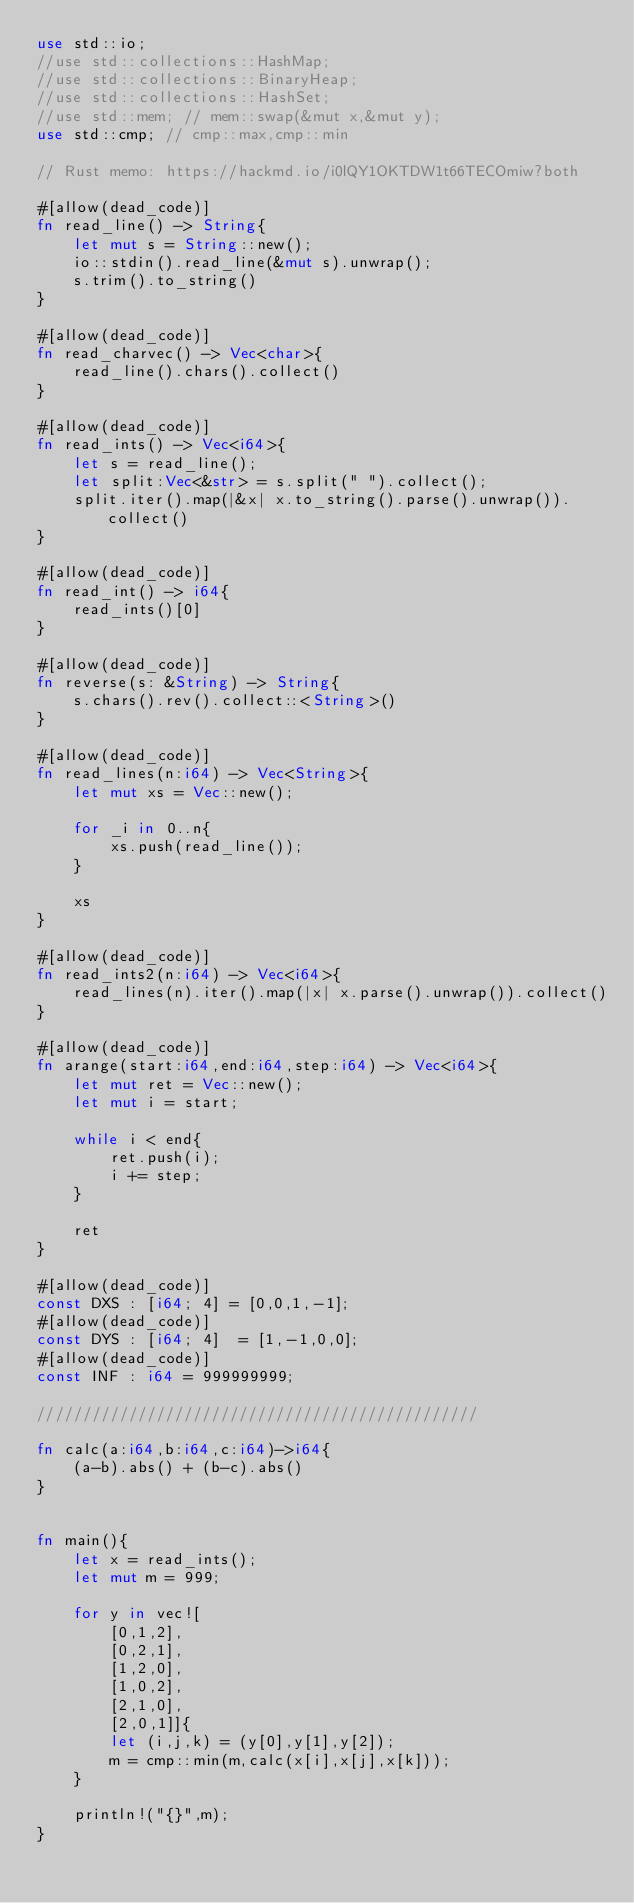Convert code to text. <code><loc_0><loc_0><loc_500><loc_500><_Rust_>use std::io;
//use std::collections::HashMap;
//use std::collections::BinaryHeap;
//use std::collections::HashSet;
//use std::mem; // mem::swap(&mut x,&mut y);
use std::cmp; // cmp::max,cmp::min

// Rust memo: https://hackmd.io/i0lQY1OKTDW1t66TECOmiw?both

#[allow(dead_code)]
fn read_line() -> String{
    let mut s = String::new();
    io::stdin().read_line(&mut s).unwrap();
    s.trim().to_string()
}

#[allow(dead_code)]
fn read_charvec() -> Vec<char>{
    read_line().chars().collect()
}

#[allow(dead_code)]
fn read_ints() -> Vec<i64>{
    let s = read_line();
    let split:Vec<&str> = s.split(" ").collect();
    split.iter().map(|&x| x.to_string().parse().unwrap()).collect()
}

#[allow(dead_code)]
fn read_int() -> i64{
    read_ints()[0]
}

#[allow(dead_code)]
fn reverse(s: &String) -> String{
    s.chars().rev().collect::<String>()
}

#[allow(dead_code)]
fn read_lines(n:i64) -> Vec<String>{
    let mut xs = Vec::new();

    for _i in 0..n{
        xs.push(read_line());
    }

    xs
}

#[allow(dead_code)]
fn read_ints2(n:i64) -> Vec<i64>{
    read_lines(n).iter().map(|x| x.parse().unwrap()).collect()
}

#[allow(dead_code)]
fn arange(start:i64,end:i64,step:i64) -> Vec<i64>{
    let mut ret = Vec::new();
    let mut i = start;

    while i < end{
        ret.push(i);
        i += step;
    }

    ret
}

#[allow(dead_code)]
const DXS : [i64; 4] = [0,0,1,-1];
#[allow(dead_code)]
const DYS : [i64; 4]  = [1,-1,0,0];
#[allow(dead_code)]
const INF : i64 = 999999999;

////////////////////////////////////////////////

fn calc(a:i64,b:i64,c:i64)->i64{
    (a-b).abs() + (b-c).abs()
}


fn main(){
    let x = read_ints();
    let mut m = 999;

    for y in vec![
        [0,1,2],
        [0,2,1],
        [1,2,0],
        [1,0,2],
        [2,1,0],
        [2,0,1]]{
        let (i,j,k) = (y[0],y[1],y[2]);
        m = cmp::min(m,calc(x[i],x[j],x[k]));
    }
    
    println!("{}",m);
}</code> 